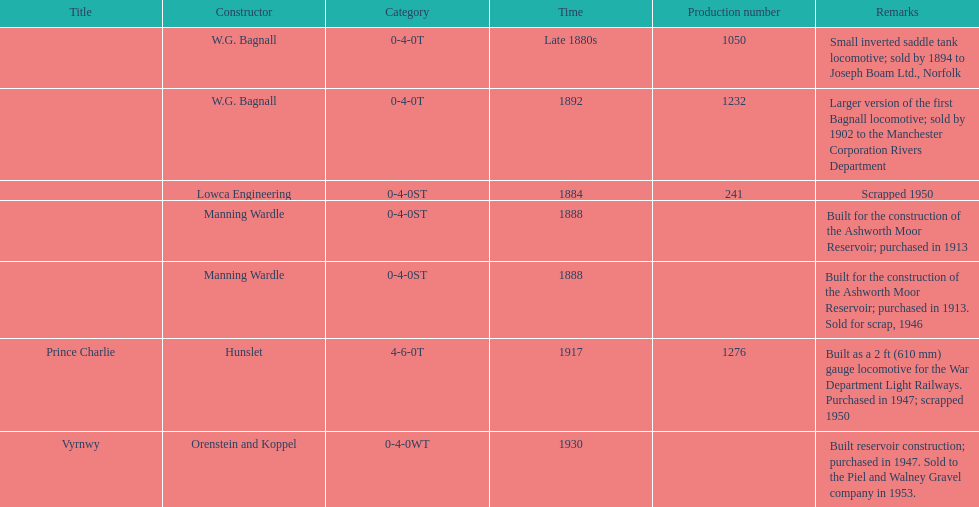How many locomotives were built for the construction of the ashworth moor reservoir? 2. 